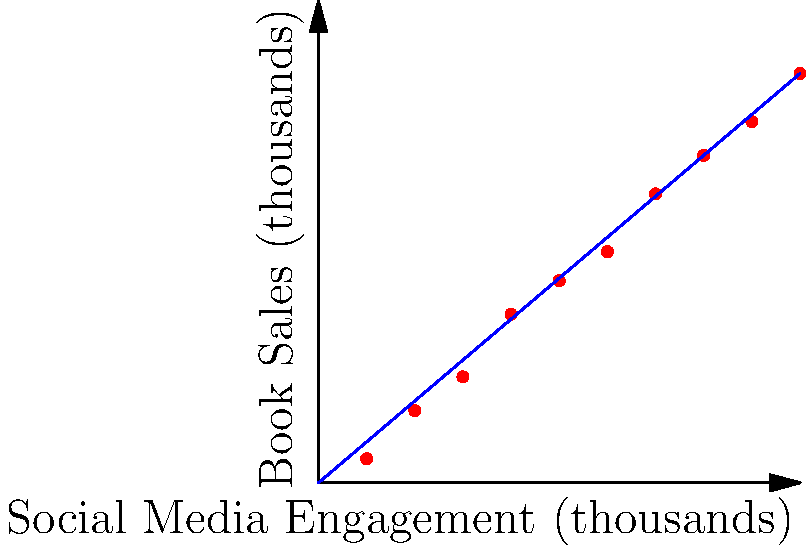Based on the scatter plot showing the relationship between social media engagement and book sales for marginalized authors, what can be concluded about the correlation between these two variables? To determine the correlation between social media engagement and book sales for marginalized authors, we need to analyze the scatter plot:

1. Observe the overall trend: The points generally move from the bottom-left to the top-right of the graph, indicating a positive relationship.

2. Assess the strength of the relationship: The points are relatively close to a straight line, suggesting a strong correlation.

3. Examine the slope: The best-fit line (blue) has a positive slope, confirming a positive correlation.

4. Calculate the correlation coefficient: While we can't calculate the exact value without the raw data, the strong linear pattern suggests a high positive correlation coefficient (likely between 0.8 and 1.0).

5. Interpret the relationship: As social media engagement increases, book sales tend to increase as well.

6. Consider outliers: There don't appear to be significant outliers that would skew the relationship.

7. Evaluate the practical significance: The strong positive correlation suggests that social media engagement could be an effective strategy for boosting book sales for marginalized authors.

Given these observations, we can conclude that there is a strong positive correlation between social media engagement and book sales for marginalized authors.
Answer: Strong positive correlation 